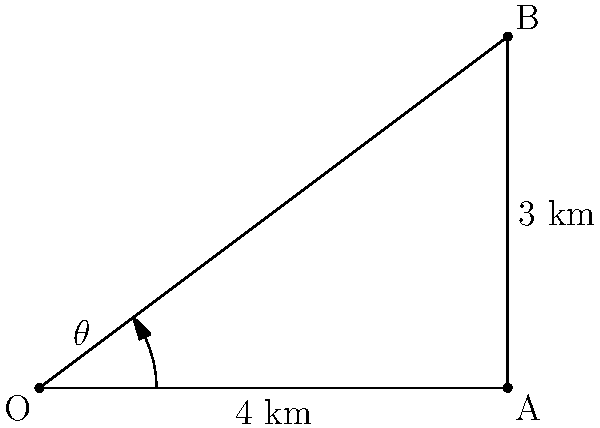As an artillery commander, you need to calculate the angle of elevation for a strike on an enemy position. The target is located 4 km east and 3 km north of your current position. Using polar coordinates, what is the angle $\theta$ (in degrees) from the positive x-axis to the target position? Round your answer to the nearest degree. To solve this problem, we'll use the arctangent function with the y and x coordinates:

1. Identify the coordinates:
   x = 4 km (east)
   y = 3 km (north)

2. Use the arctangent function:
   $\theta = \arctan(\frac{y}{x})$

3. Plug in the values:
   $\theta = \arctan(\frac{3}{4})$

4. Calculate:
   $\theta \approx 0.6435$ radians

5. Convert radians to degrees:
   $\theta_{degrees} = \theta_{radians} \times \frac{180^{\circ}}{\pi}$
   $\theta_{degrees} \approx 0.6435 \times \frac{180^{\circ}}{\pi} \approx 36.87^{\circ}$

6. Round to the nearest degree:
   $\theta \approx 37^{\circ}$

Therefore, the angle of elevation for the artillery strike is approximately 37 degrees from the positive x-axis.
Answer: $37^{\circ}$ 